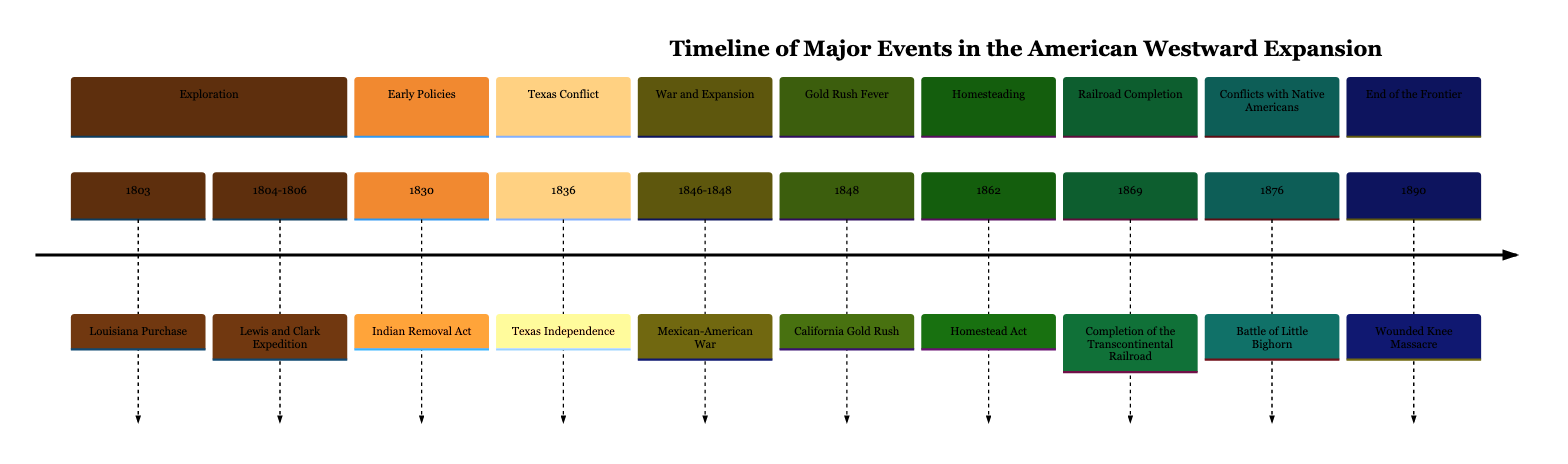What event occurred in 1804-1806? Referring to the timeline, we need to locate the specific section corresponding to the year range of 1804-1806. In the Exploration section, it states that the Lewis and Clark Expedition took place during these years.
Answer: Lewis and Clark Expedition Which act was passed in 1830? By examining the Early Policies section of the timeline, the Indian Removal Act is listed as occurring in the year 1830.
Answer: Indian Removal Act How many major events are listed in the time period from 1800 to 1850? We count the events that appear in the timeline from the Exploration (1803, 1804-1806), Early Policies (1830), Texas Conflict (1836), War and Expansion (1846-1848), and Gold Rush Fever (1848). This gives us a total of 5 events.
Answer: 5 What was the outcome of the Mexican-American War? We look closely at the War and Expansion section; although it mentions a specific war, it doesn’t directly state an "outcome." However, it implies expansion through its context. The war concluded with territorial gains for the U.S.
Answer: Territorial expansion What year did the Homestead Act take place? The Homesteading section clearly marks the year of the Homestead Act as 1862. Therefore, identifying the Homesteading section provides the answer quickly.
Answer: 1862 What major event occurred in 1876? By checking the Conflicts with Native Americans section, we find that the Battle of Little Bighorn occurred in 1876.
Answer: Battle of Little Bighorn What was significant about the year 1869? The Railroad Completion section indicates that 1869 is significant for the completion of the Transcontinental Railroad, a major milestone in American history.
Answer: Completion of the Transcontinental Railroad In what year did the Wounded Knee Massacre happen? The End of the Frontier section shows that the Wounded Knee Massacre took place in 1890. Therefore, the year can be found straightforwardly in this section.
Answer: 1890 